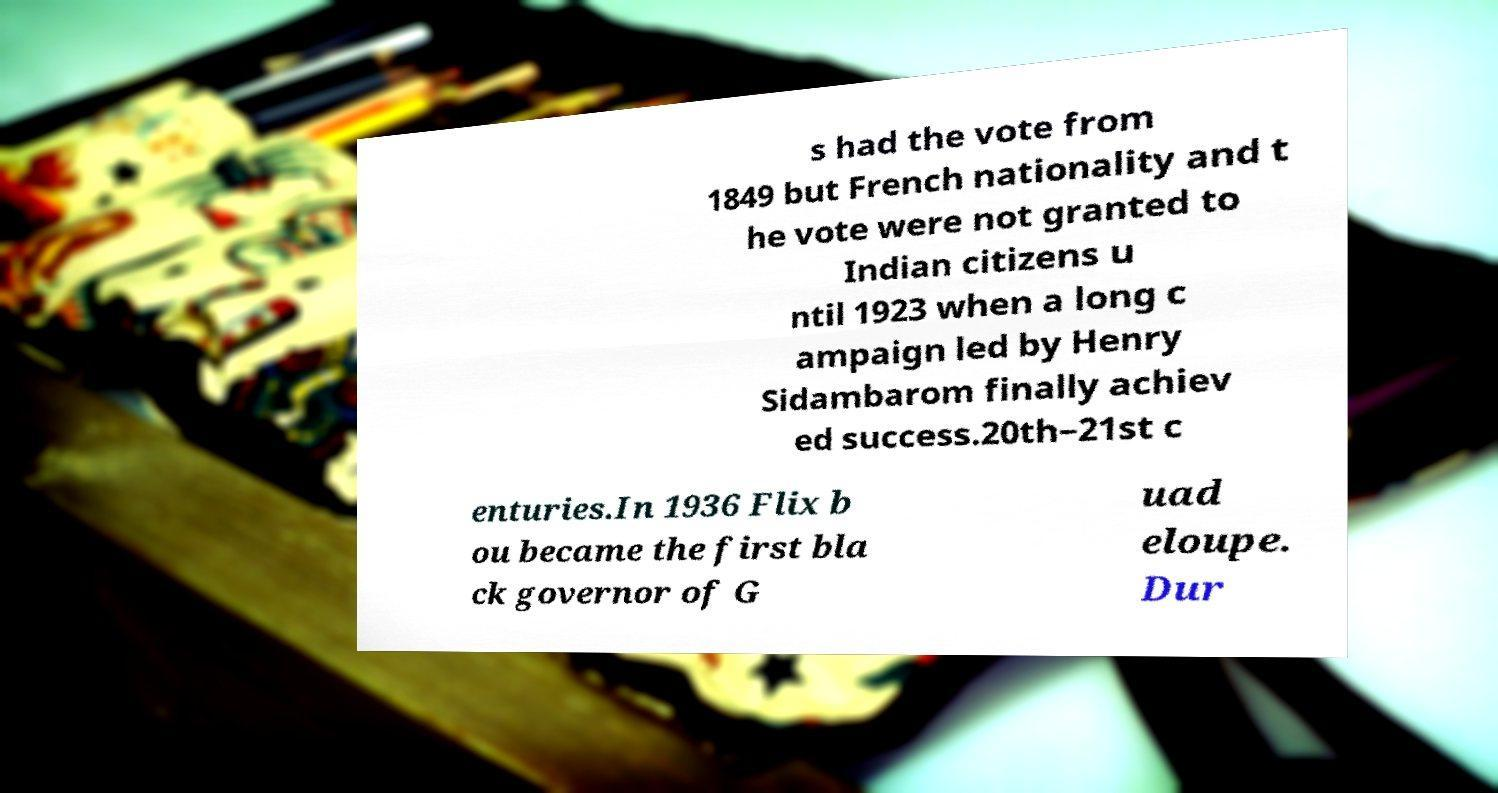There's text embedded in this image that I need extracted. Can you transcribe it verbatim? s had the vote from 1849 but French nationality and t he vote were not granted to Indian citizens u ntil 1923 when a long c ampaign led by Henry Sidambarom finally achiev ed success.20th–21st c enturies.In 1936 Flix b ou became the first bla ck governor of G uad eloupe. Dur 